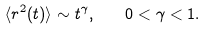<formula> <loc_0><loc_0><loc_500><loc_500>\langle r ^ { 2 } ( t ) \rangle \sim t ^ { \gamma } , \quad 0 < \gamma < 1 .</formula> 